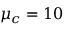Convert formula to latex. <formula><loc_0><loc_0><loc_500><loc_500>\mu _ { c } = 1 0</formula> 